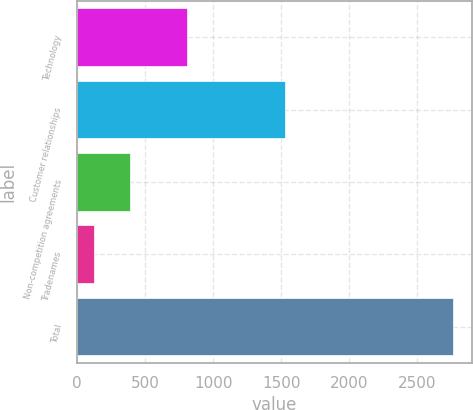<chart> <loc_0><loc_0><loc_500><loc_500><bar_chart><fcel>Technology<fcel>Customer relationships<fcel>Non-competition agreements<fcel>Tradenames<fcel>Total<nl><fcel>808<fcel>1531<fcel>386.7<fcel>123<fcel>2760<nl></chart> 